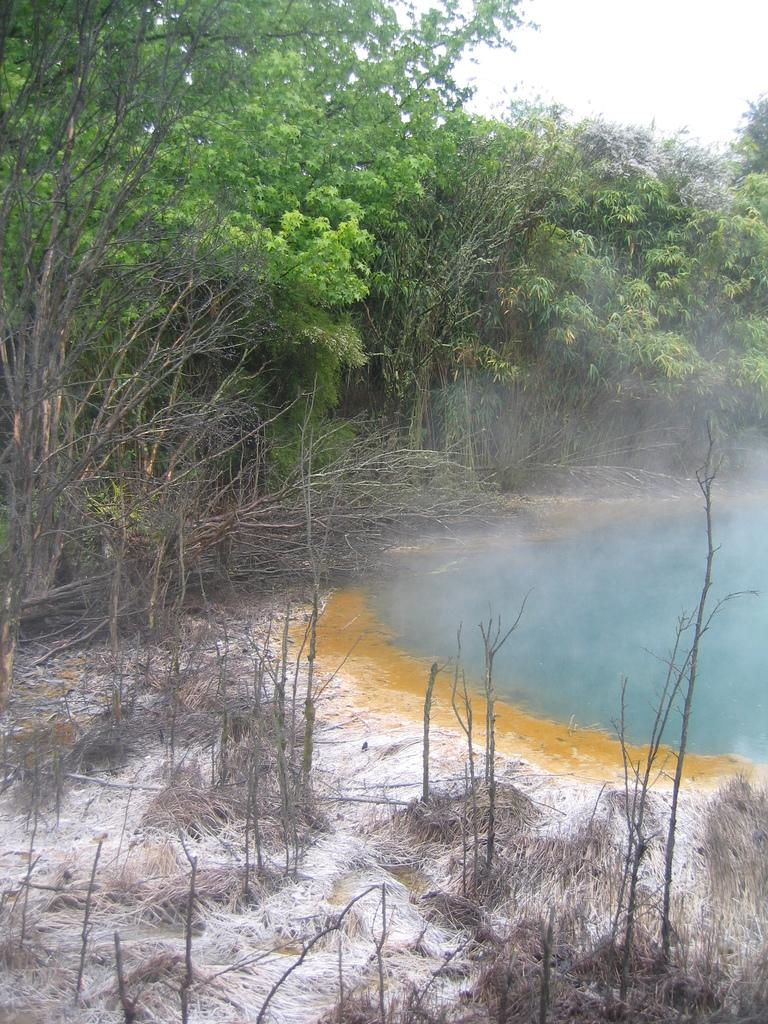What type of vegetation is at the bottom of the image? There is grass at the bottom of the image. What substance is present in the image? There is white powder in the image. What can be seen in the background of the image? There is a pond, trees, grass, and fog in the background of the image. What is visible at the top of the image? The sky is visible at the top of the image. What type of thread is being used to create the love symbol in the image? There is no love symbol or thread present in the image. How many fingers are visible in the image? There is no reference to fingers in the image, so it is not possible to answer that question. 